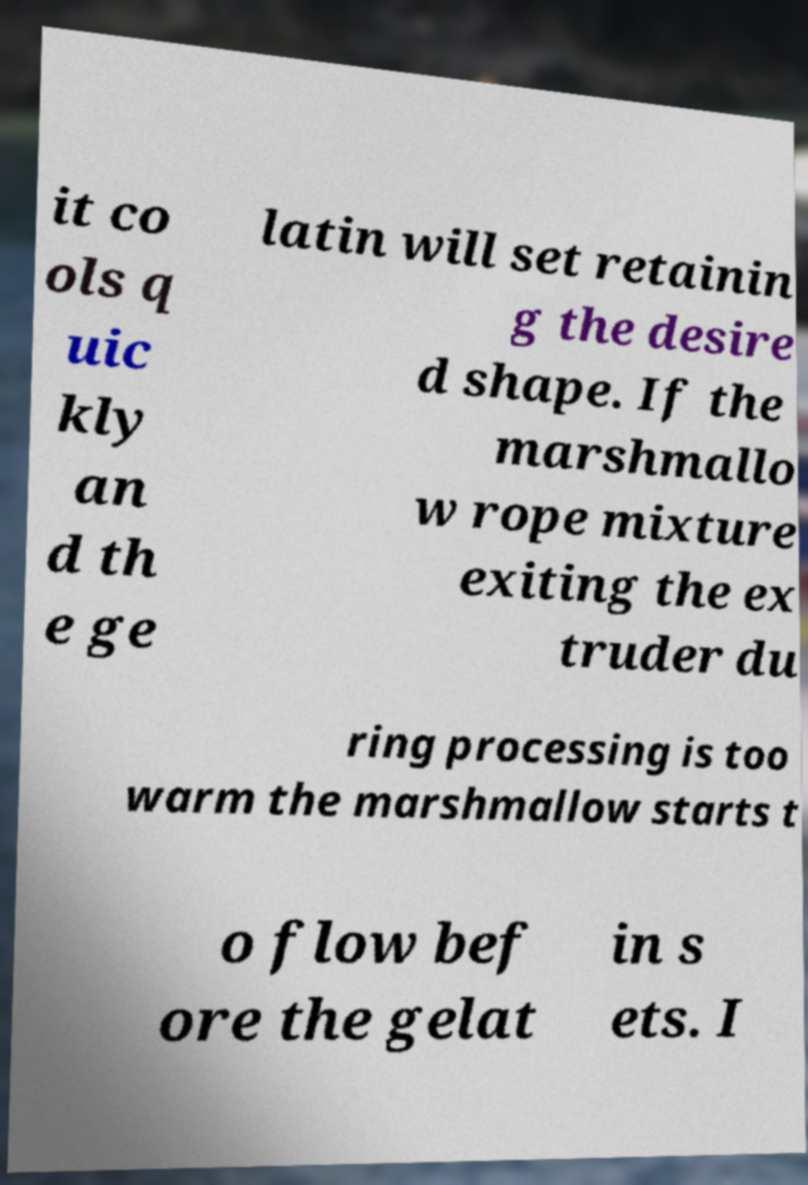Please identify and transcribe the text found in this image. it co ols q uic kly an d th e ge latin will set retainin g the desire d shape. If the marshmallo w rope mixture exiting the ex truder du ring processing is too warm the marshmallow starts t o flow bef ore the gelat in s ets. I 